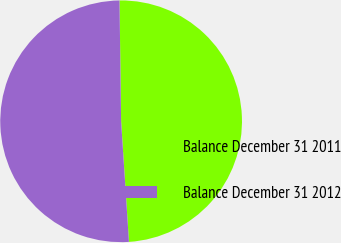Convert chart. <chart><loc_0><loc_0><loc_500><loc_500><pie_chart><fcel>Balance December 31 2011<fcel>Balance December 31 2012<nl><fcel>49.18%<fcel>50.82%<nl></chart> 